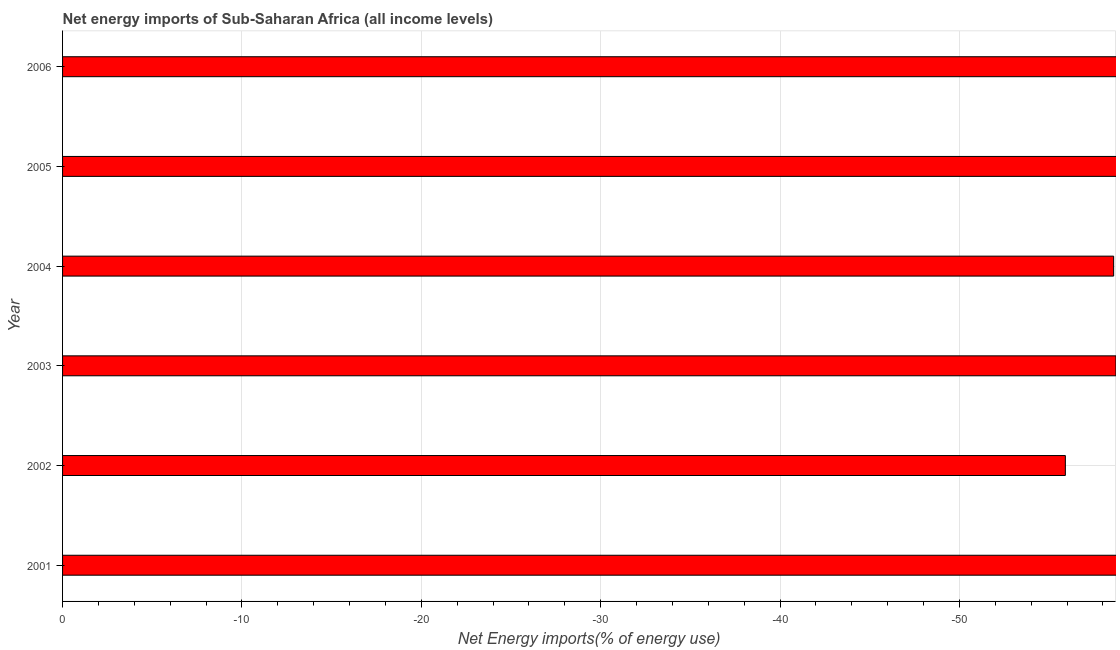Does the graph contain grids?
Give a very brief answer. Yes. What is the title of the graph?
Your answer should be compact. Net energy imports of Sub-Saharan Africa (all income levels). What is the label or title of the X-axis?
Provide a succinct answer. Net Energy imports(% of energy use). What is the label or title of the Y-axis?
Make the answer very short. Year. What is the energy imports in 2001?
Keep it short and to the point. 0. Across all years, what is the minimum energy imports?
Give a very brief answer. 0. What is the median energy imports?
Provide a succinct answer. 0. In how many years, is the energy imports greater than the average energy imports taken over all years?
Make the answer very short. 0. What is the difference between two consecutive major ticks on the X-axis?
Your response must be concise. 10. Are the values on the major ticks of X-axis written in scientific E-notation?
Offer a very short reply. No. What is the Net Energy imports(% of energy use) of 2004?
Give a very brief answer. 0. 